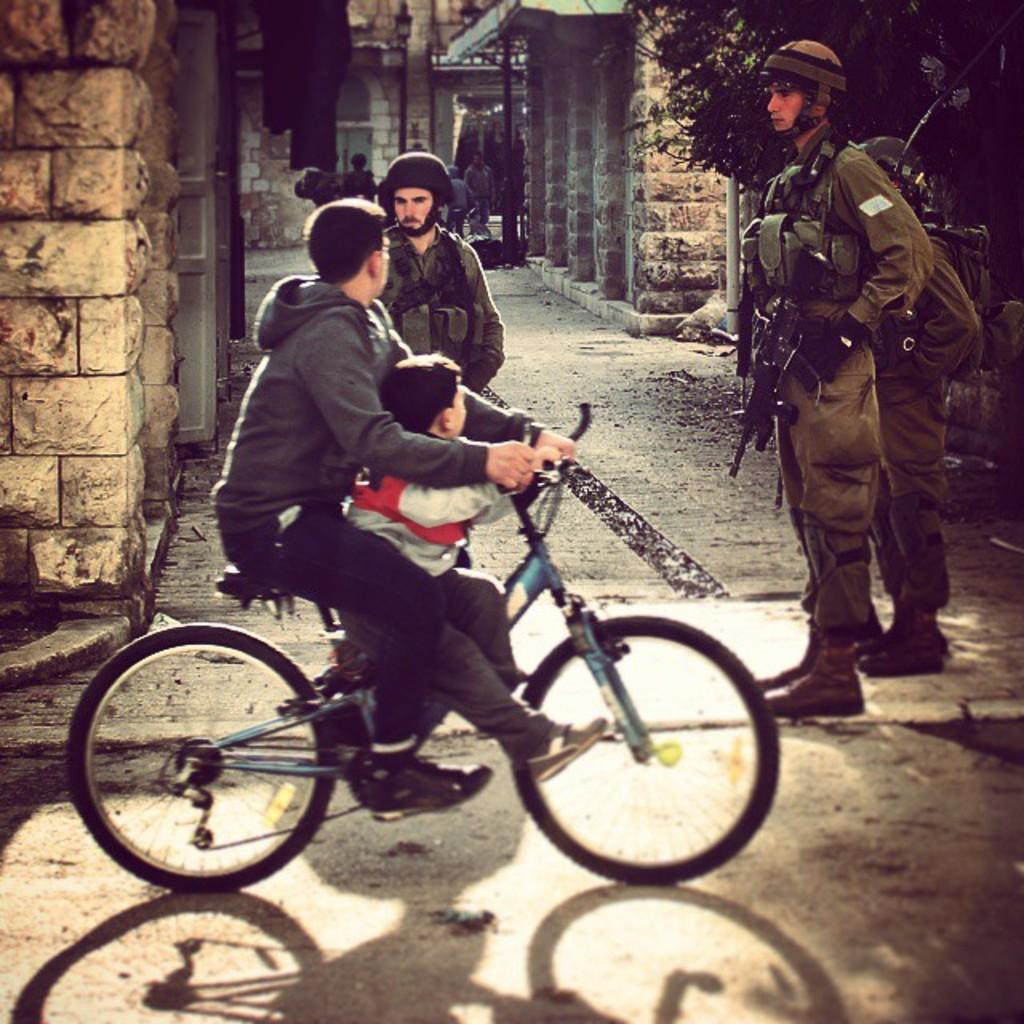How many people are in the group shown in the image? There is a group of people in the image, and three of them are soldiers. What are the soldiers holding in the image? The soldiers are holding guns in the image. What are the two boys in the group doing? The two boys in the group are riding bicycles. What can be observed about the soldiers' appearance in the image? The soldiers are in uniform in the image. How many goldfish can be seen swimming in the tub in the image? There are no goldfish or tub present in the image. What type of lizards are crawling on the soldiers' uniforms in the image? There are no lizards visible on the soldiers' uniforms in the image. 